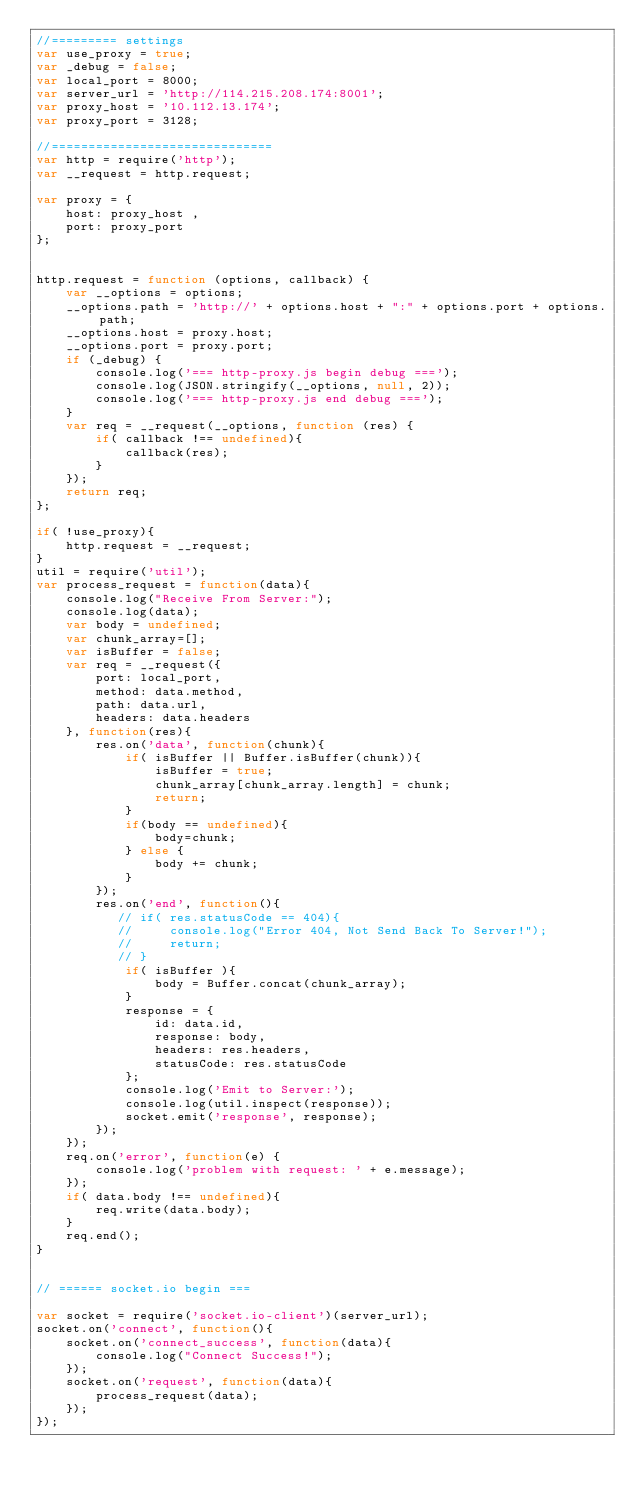Convert code to text. <code><loc_0><loc_0><loc_500><loc_500><_JavaScript_>//========= settings
var use_proxy = true;
var _debug = false;
var local_port = 8000;
var server_url = 'http://114.215.208.174:8001';
var proxy_host = '10.112.13.174';
var proxy_port = 3128;

//==============================
var http = require('http');
var __request = http.request;

var proxy = {
    host: proxy_host ,
    port: proxy_port
};
 
 
http.request = function (options, callback) {
    var __options = options;
    __options.path = 'http://' + options.host + ":" + options.port + options.path;
    __options.host = proxy.host;
    __options.port = proxy.port;
    if (_debug) {
        console.log('=== http-proxy.js begin debug ===');
        console.log(JSON.stringify(__options, null, 2));
        console.log('=== http-proxy.js end debug ===');
    }
    var req = __request(__options, function (res) {
        if( callback !== undefined){
            callback(res);
        }
    });
    return req;
};

if( !use_proxy){
    http.request = __request;
}
util = require('util');
var process_request = function(data){
    console.log("Receive From Server:");
    console.log(data);
    var body = undefined;
    var chunk_array=[];
    var isBuffer = false;
    var req = __request({
        port: local_port,
        method: data.method,
        path: data.url,
        headers: data.headers
    }, function(res){
        res.on('data', function(chunk){
            if( isBuffer || Buffer.isBuffer(chunk)){
                isBuffer = true;
                chunk_array[chunk_array.length] = chunk;
                return;
            }            
            if(body == undefined){
                body=chunk;
            } else {
                body += chunk;
            }
        });
        res.on('end', function(){
           // if( res.statusCode == 404){
           //     console.log("Error 404, Not Send Back To Server!");
           //     return;
           // }
            if( isBuffer ){
                body = Buffer.concat(chunk_array);
            }
            response = { 
                id: data.id,
                response: body,
                headers: res.headers,
                statusCode: res.statusCode
            };
            console.log('Emit to Server:');
            console.log(util.inspect(response));
            socket.emit('response', response);
        });
    });
    req.on('error', function(e) {
        console.log('problem with request: ' + e.message);
    });
    if( data.body !== undefined){
        req.write(data.body);
    }
    req.end();
}


// ====== socket.io begin ===

var socket = require('socket.io-client')(server_url);
socket.on('connect', function(){
    socket.on('connect_success', function(data){
        console.log("Connect Success!");
    });
    socket.on('request', function(data){
        process_request(data);
    });
});

</code> 